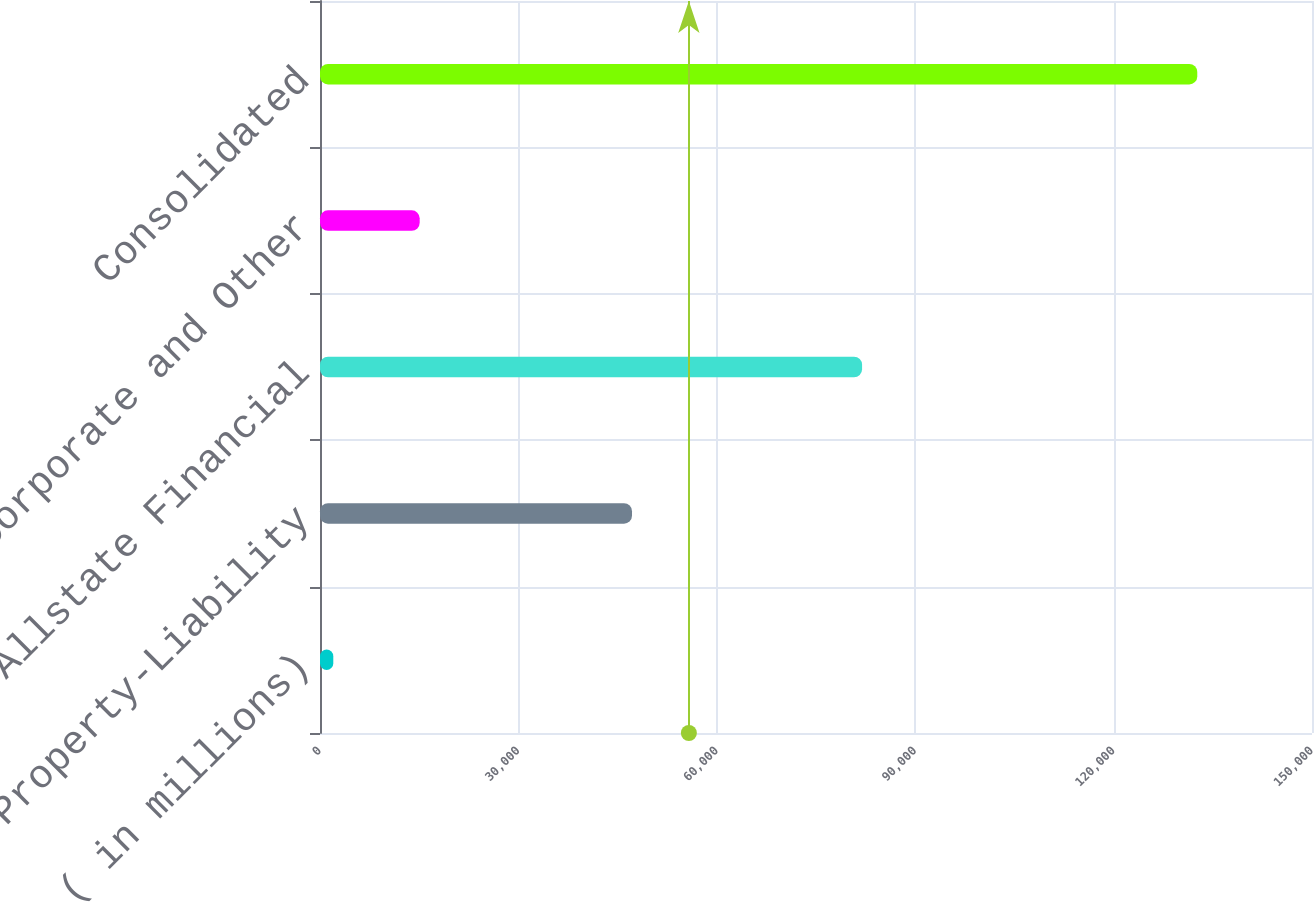<chart> <loc_0><loc_0><loc_500><loc_500><bar_chart><fcel>( in millions)<fcel>Property-Liability<fcel>Allstate Financial<fcel>Corporate and Other<fcel>Consolidated<nl><fcel>2009<fcel>47179<fcel>81968<fcel>15073.3<fcel>132652<nl></chart> 